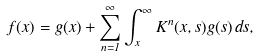<formula> <loc_0><loc_0><loc_500><loc_500>f ( x ) = g ( x ) + \sum _ { n = 1 } ^ { \infty } \int _ { x } ^ { \infty } K ^ { n } ( x , s ) g ( s ) \, d s ,</formula> 